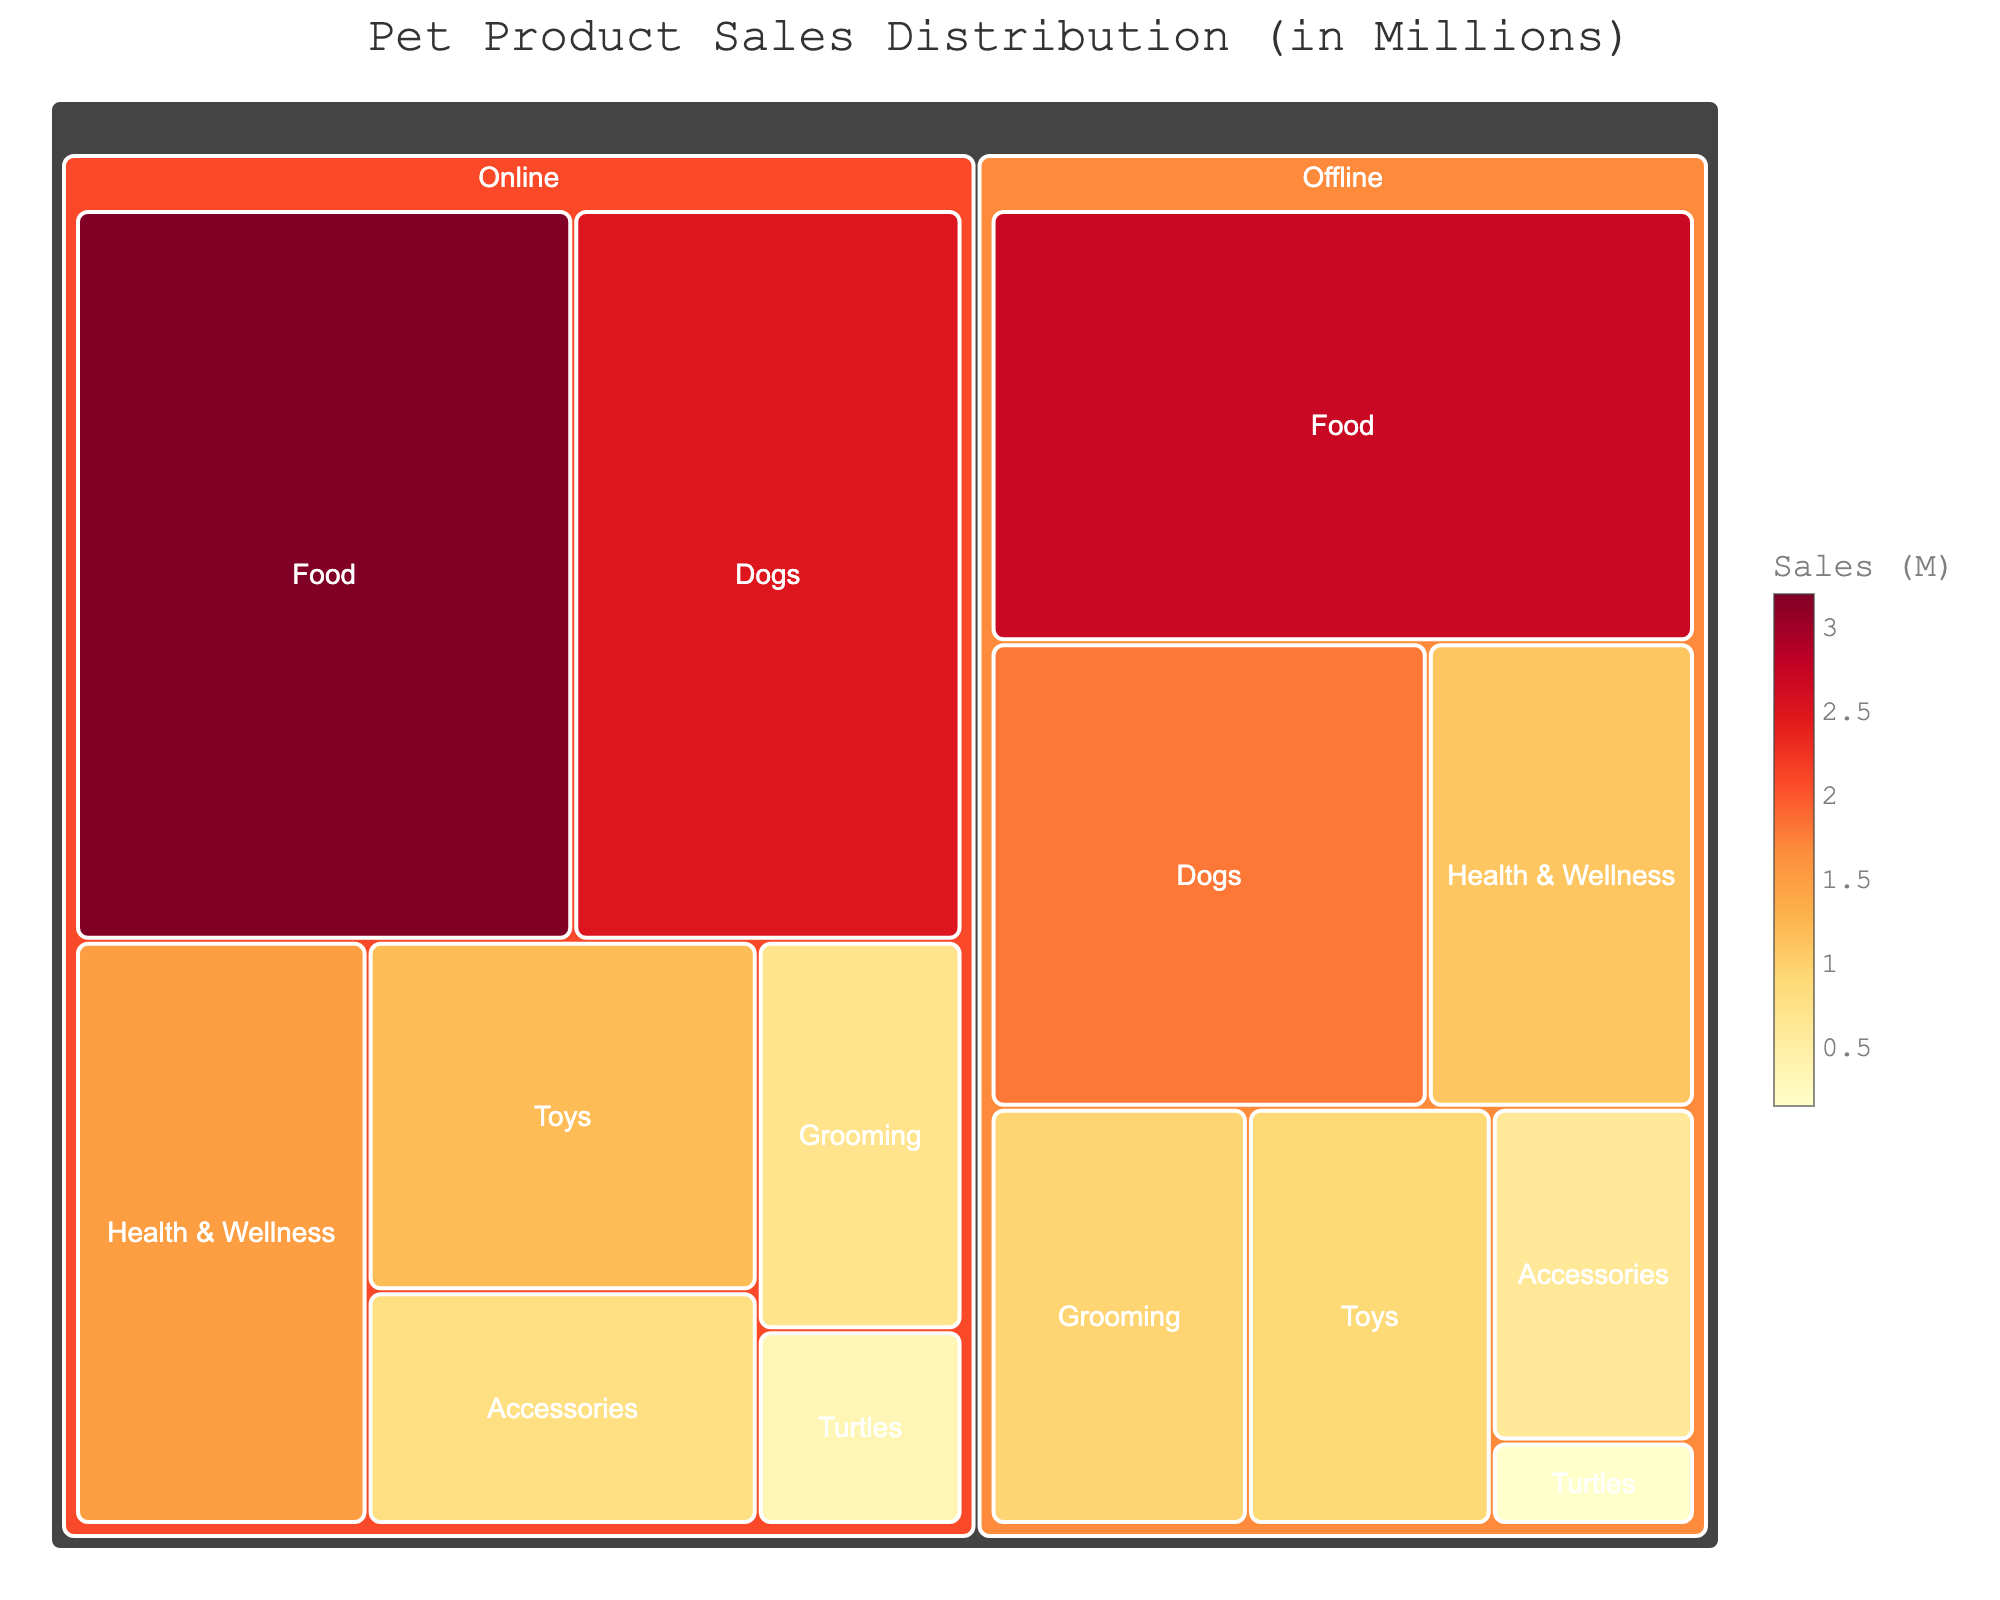What's the title of the figure? The title is prominently displayed at the top center of the figure.
Answer: Pet Product Sales Distribution (in Millions) Which category has the highest online sales? By visually examining the treemap, the largest online sales block is for "Food."
Answer: Food What is the total offline sales for all categories combined? Sum the offline sales from each category: Dogs ($1.8M), Turtles ($0.15M), Food ($2.7M), Toys ($0.9M), Accessories ($0.6M), Health & Wellness ($1.1M), Grooming ($0.95M). Total is $8.2M.
Answer: $8.2M Compare the sales of "Dogs" between online and offline channels. Which one is greater, and by how much? Online sales for Dogs ($2.5M) and Offline sales for Dogs ($1.8M). Online is greater by $2.5M - $1.8M = $0.7M.
Answer: Online, $0.7M How do the online sales for "Accessories" compare to the offline sales for "Toys"? Online sales for Accessories is $0.8M; Offline sales for Toys is $0.9M. Offline sales for Toys is greater by $0.1M.
Answer: Offline for Toys, $0.1M What percentage of total sales does the "Health & Wellness" category represent in online sales? Total online sales is the sum of all online category sales: $2.5M (Dogs) + $0.35M (Turtles) + $3.2M (Food) + $1.2M (Toys) + $0.8M (Accessories) + $1.5M (Health & Wellness) + $0.7M (Grooming) = $10.25M. The percentage is ($1.5M / $10.25M) * 100%.
Answer: 14.63% Which channel has higher sales for the "Grooming" category, and by how much? Online sales for Grooming is $0.7M; Offline sales for Grooming is $0.95M. Offline is greater by $0.95M - $0.7M = $0.25M.
Answer: Offline, $0.25M What is the least sales-generating category overall, combining both channels? Combining online and offline sales for each category shows Turtles have the lowest total ($0.35M + $0.15M = $0.5M).
Answer: Turtles If we merge the sales of "Toys" and "Accessories," what would be their combined total sales? Sum the sales of Toys ($1.2M online + $0.9M offline) and Accessories ($0.8M online + $0.6M offline): $2.1M + $1.4M = $3.5M.
Answer: $3.5M 